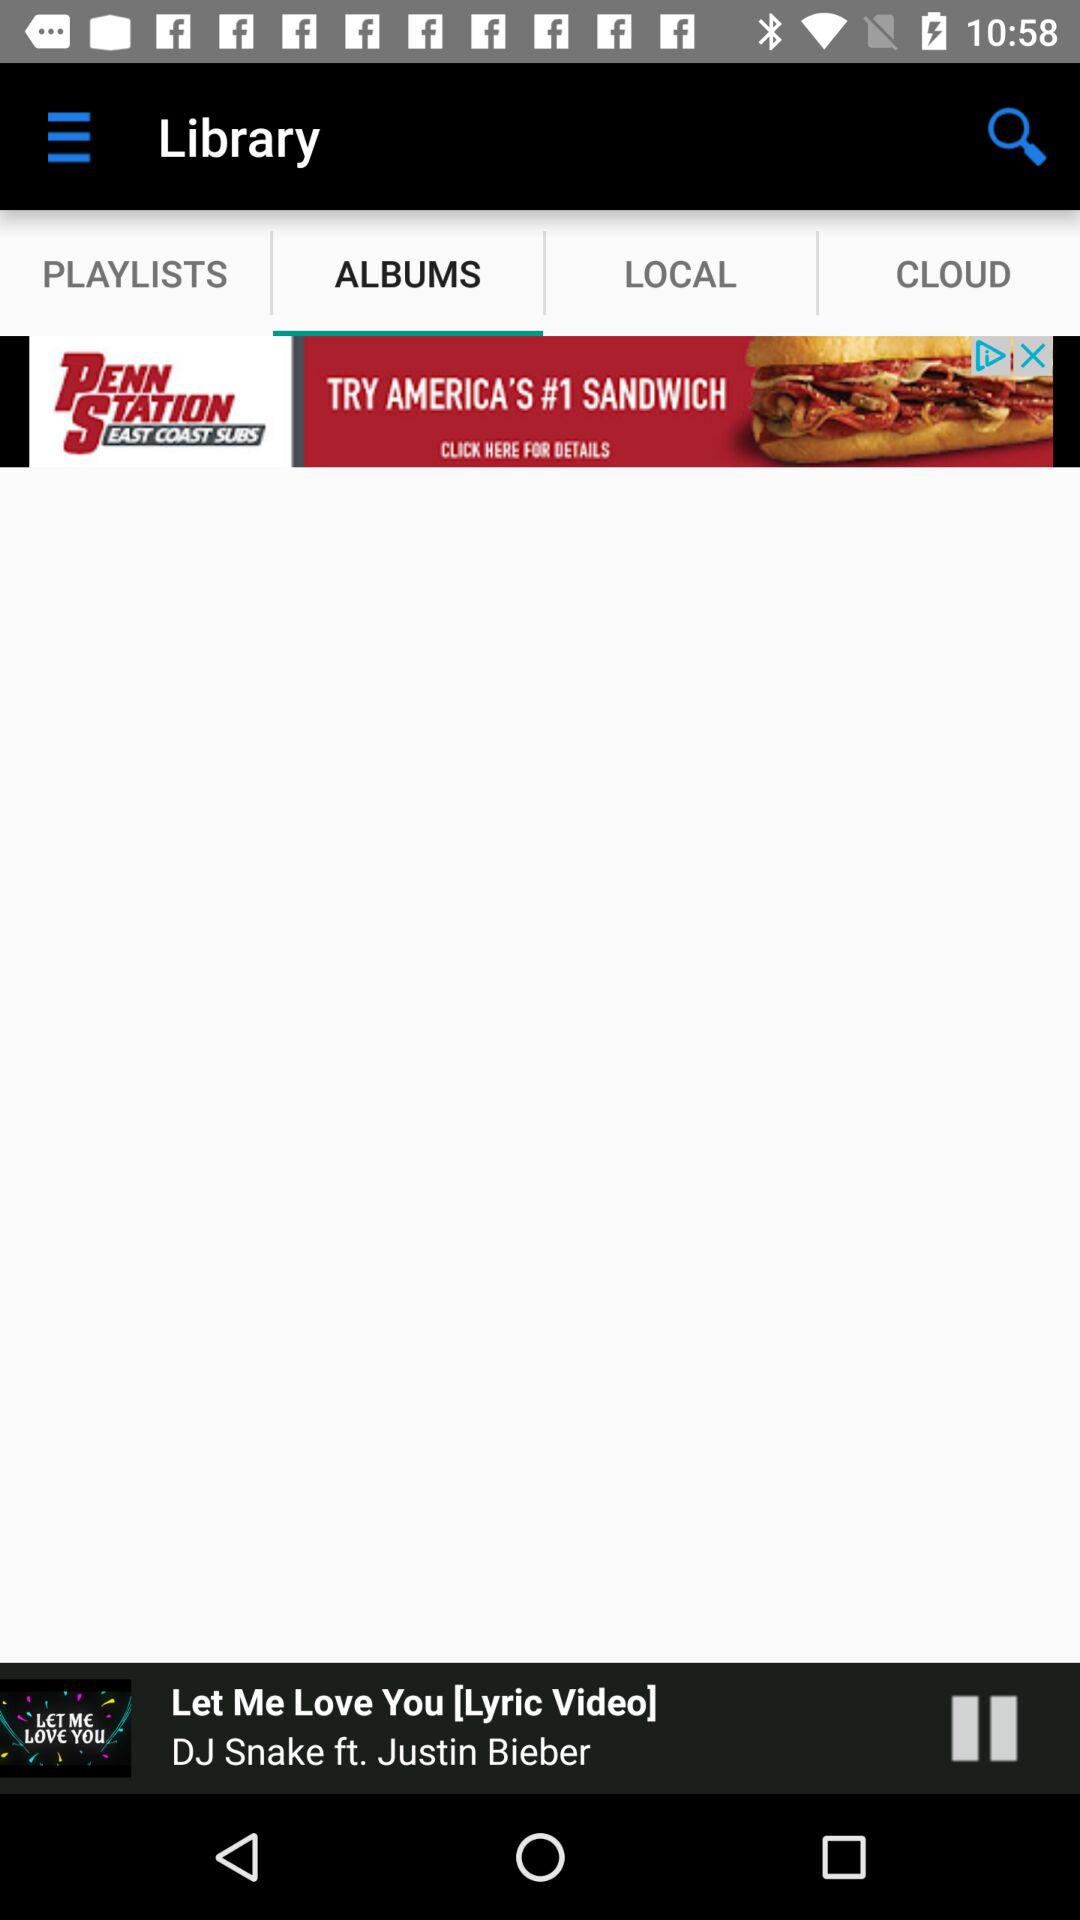What is the singer name of the current playing song? The name of the singer is Justin Bieber. 